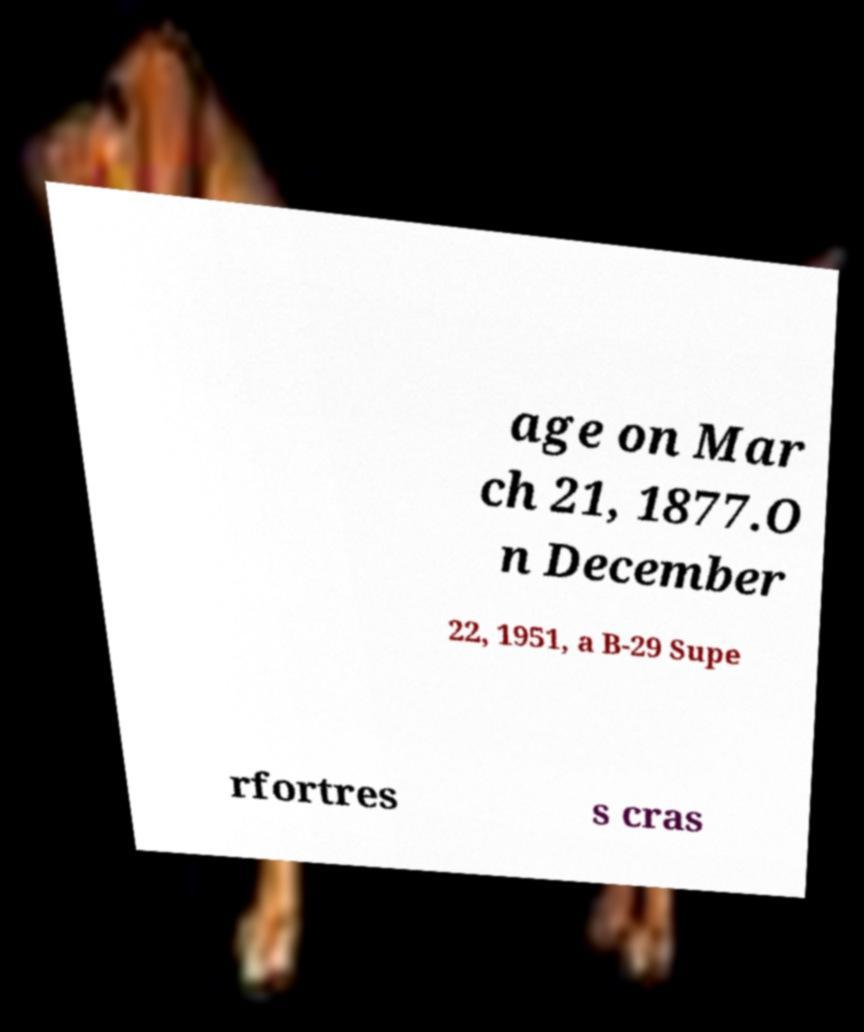Could you extract and type out the text from this image? age on Mar ch 21, 1877.O n December 22, 1951, a B-29 Supe rfortres s cras 